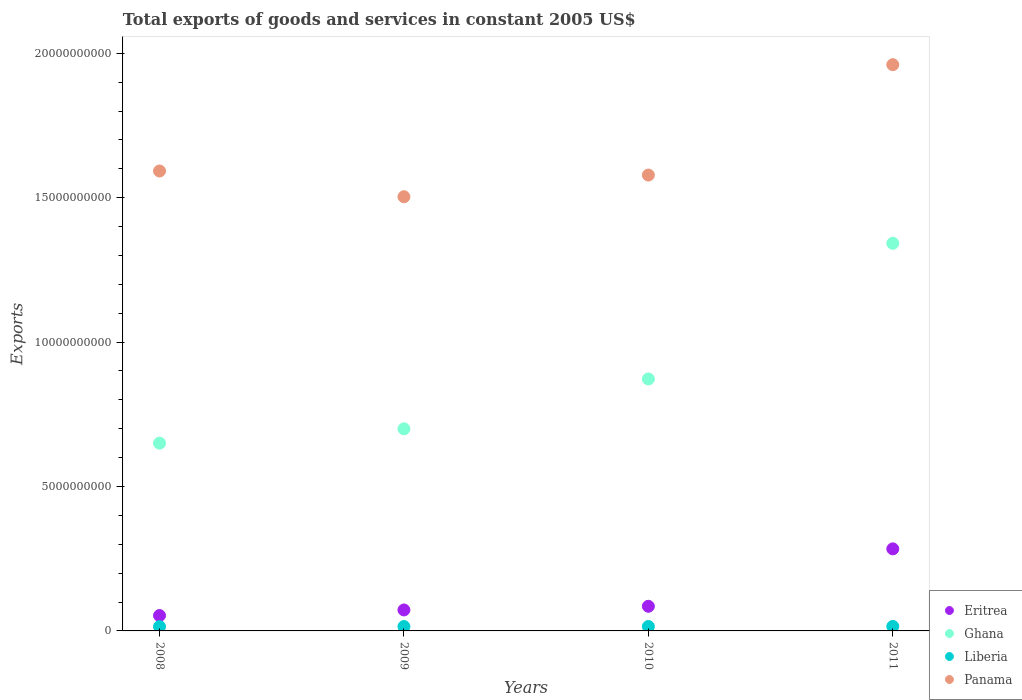How many different coloured dotlines are there?
Your answer should be compact. 4. What is the total exports of goods and services in Eritrea in 2011?
Your answer should be compact. 2.84e+09. Across all years, what is the maximum total exports of goods and services in Liberia?
Make the answer very short. 1.55e+08. Across all years, what is the minimum total exports of goods and services in Ghana?
Ensure brevity in your answer.  6.50e+09. What is the total total exports of goods and services in Liberia in the graph?
Ensure brevity in your answer.  6.09e+08. What is the difference between the total exports of goods and services in Panama in 2009 and that in 2011?
Your answer should be very brief. -4.57e+09. What is the difference between the total exports of goods and services in Ghana in 2008 and the total exports of goods and services in Panama in 2010?
Your answer should be compact. -9.28e+09. What is the average total exports of goods and services in Panama per year?
Give a very brief answer. 1.66e+1. In the year 2010, what is the difference between the total exports of goods and services in Ghana and total exports of goods and services in Panama?
Provide a short and direct response. -7.06e+09. What is the ratio of the total exports of goods and services in Eritrea in 2008 to that in 2011?
Give a very brief answer. 0.19. Is the difference between the total exports of goods and services in Ghana in 2010 and 2011 greater than the difference between the total exports of goods and services in Panama in 2010 and 2011?
Your answer should be compact. No. What is the difference between the highest and the second highest total exports of goods and services in Eritrea?
Ensure brevity in your answer.  1.99e+09. What is the difference between the highest and the lowest total exports of goods and services in Panama?
Your response must be concise. 4.57e+09. In how many years, is the total exports of goods and services in Ghana greater than the average total exports of goods and services in Ghana taken over all years?
Your response must be concise. 1. Is it the case that in every year, the sum of the total exports of goods and services in Panama and total exports of goods and services in Liberia  is greater than the sum of total exports of goods and services in Ghana and total exports of goods and services in Eritrea?
Make the answer very short. No. Does the total exports of goods and services in Ghana monotonically increase over the years?
Give a very brief answer. Yes. Is the total exports of goods and services in Liberia strictly greater than the total exports of goods and services in Eritrea over the years?
Ensure brevity in your answer.  No. How many dotlines are there?
Your answer should be compact. 4. How many years are there in the graph?
Make the answer very short. 4. What is the difference between two consecutive major ticks on the Y-axis?
Your answer should be compact. 5.00e+09. Does the graph contain any zero values?
Your response must be concise. No. Where does the legend appear in the graph?
Give a very brief answer. Bottom right. How are the legend labels stacked?
Your answer should be very brief. Vertical. What is the title of the graph?
Offer a terse response. Total exports of goods and services in constant 2005 US$. What is the label or title of the Y-axis?
Offer a very short reply. Exports. What is the Exports of Eritrea in 2008?
Your answer should be very brief. 5.33e+08. What is the Exports of Ghana in 2008?
Ensure brevity in your answer.  6.50e+09. What is the Exports in Liberia in 2008?
Offer a very short reply. 1.49e+08. What is the Exports in Panama in 2008?
Provide a short and direct response. 1.59e+1. What is the Exports in Eritrea in 2009?
Ensure brevity in your answer.  7.26e+08. What is the Exports in Ghana in 2009?
Your response must be concise. 7.00e+09. What is the Exports in Liberia in 2009?
Your answer should be very brief. 1.51e+08. What is the Exports in Panama in 2009?
Provide a short and direct response. 1.50e+1. What is the Exports of Eritrea in 2010?
Provide a succinct answer. 8.53e+08. What is the Exports of Ghana in 2010?
Make the answer very short. 8.72e+09. What is the Exports of Liberia in 2010?
Your answer should be compact. 1.53e+08. What is the Exports of Panama in 2010?
Give a very brief answer. 1.58e+1. What is the Exports of Eritrea in 2011?
Your answer should be very brief. 2.84e+09. What is the Exports in Ghana in 2011?
Ensure brevity in your answer.  1.34e+1. What is the Exports in Liberia in 2011?
Make the answer very short. 1.55e+08. What is the Exports of Panama in 2011?
Provide a short and direct response. 1.96e+1. Across all years, what is the maximum Exports of Eritrea?
Give a very brief answer. 2.84e+09. Across all years, what is the maximum Exports of Ghana?
Your response must be concise. 1.34e+1. Across all years, what is the maximum Exports of Liberia?
Offer a very short reply. 1.55e+08. Across all years, what is the maximum Exports in Panama?
Give a very brief answer. 1.96e+1. Across all years, what is the minimum Exports in Eritrea?
Provide a short and direct response. 5.33e+08. Across all years, what is the minimum Exports of Ghana?
Your answer should be compact. 6.50e+09. Across all years, what is the minimum Exports of Liberia?
Offer a very short reply. 1.49e+08. Across all years, what is the minimum Exports in Panama?
Your answer should be compact. 1.50e+1. What is the total Exports of Eritrea in the graph?
Offer a very short reply. 4.95e+09. What is the total Exports in Ghana in the graph?
Your answer should be very brief. 3.56e+1. What is the total Exports in Liberia in the graph?
Give a very brief answer. 6.09e+08. What is the total Exports of Panama in the graph?
Make the answer very short. 6.63e+1. What is the difference between the Exports of Eritrea in 2008 and that in 2009?
Your answer should be very brief. -1.93e+08. What is the difference between the Exports of Ghana in 2008 and that in 2009?
Provide a short and direct response. -4.95e+08. What is the difference between the Exports of Liberia in 2008 and that in 2009?
Offer a terse response. -1.98e+06. What is the difference between the Exports in Panama in 2008 and that in 2009?
Offer a terse response. 8.90e+08. What is the difference between the Exports of Eritrea in 2008 and that in 2010?
Make the answer very short. -3.20e+08. What is the difference between the Exports in Ghana in 2008 and that in 2010?
Ensure brevity in your answer.  -2.22e+09. What is the difference between the Exports of Liberia in 2008 and that in 2010?
Your answer should be compact. -3.98e+06. What is the difference between the Exports of Panama in 2008 and that in 2010?
Provide a short and direct response. 1.40e+08. What is the difference between the Exports of Eritrea in 2008 and that in 2011?
Give a very brief answer. -2.31e+09. What is the difference between the Exports in Ghana in 2008 and that in 2011?
Keep it short and to the point. -6.92e+09. What is the difference between the Exports of Liberia in 2008 and that in 2011?
Make the answer very short. -6.07e+06. What is the difference between the Exports of Panama in 2008 and that in 2011?
Your answer should be very brief. -3.68e+09. What is the difference between the Exports in Eritrea in 2009 and that in 2010?
Provide a short and direct response. -1.27e+08. What is the difference between the Exports of Ghana in 2009 and that in 2010?
Provide a succinct answer. -1.73e+09. What is the difference between the Exports of Liberia in 2009 and that in 2010?
Give a very brief answer. -2.00e+06. What is the difference between the Exports in Panama in 2009 and that in 2010?
Your answer should be compact. -7.51e+08. What is the difference between the Exports in Eritrea in 2009 and that in 2011?
Your answer should be very brief. -2.12e+09. What is the difference between the Exports of Ghana in 2009 and that in 2011?
Your answer should be compact. -6.42e+09. What is the difference between the Exports of Liberia in 2009 and that in 2011?
Provide a succinct answer. -4.09e+06. What is the difference between the Exports in Panama in 2009 and that in 2011?
Give a very brief answer. -4.57e+09. What is the difference between the Exports in Eritrea in 2010 and that in 2011?
Your answer should be compact. -1.99e+09. What is the difference between the Exports in Ghana in 2010 and that in 2011?
Your response must be concise. -4.70e+09. What is the difference between the Exports of Liberia in 2010 and that in 2011?
Provide a short and direct response. -2.09e+06. What is the difference between the Exports in Panama in 2010 and that in 2011?
Offer a very short reply. -3.82e+09. What is the difference between the Exports of Eritrea in 2008 and the Exports of Ghana in 2009?
Ensure brevity in your answer.  -6.46e+09. What is the difference between the Exports in Eritrea in 2008 and the Exports in Liberia in 2009?
Offer a very short reply. 3.82e+08. What is the difference between the Exports in Eritrea in 2008 and the Exports in Panama in 2009?
Offer a terse response. -1.45e+1. What is the difference between the Exports in Ghana in 2008 and the Exports in Liberia in 2009?
Your response must be concise. 6.35e+09. What is the difference between the Exports in Ghana in 2008 and the Exports in Panama in 2009?
Ensure brevity in your answer.  -8.53e+09. What is the difference between the Exports of Liberia in 2008 and the Exports of Panama in 2009?
Provide a short and direct response. -1.49e+1. What is the difference between the Exports of Eritrea in 2008 and the Exports of Ghana in 2010?
Your answer should be compact. -8.19e+09. What is the difference between the Exports of Eritrea in 2008 and the Exports of Liberia in 2010?
Provide a short and direct response. 3.80e+08. What is the difference between the Exports of Eritrea in 2008 and the Exports of Panama in 2010?
Your response must be concise. -1.52e+1. What is the difference between the Exports of Ghana in 2008 and the Exports of Liberia in 2010?
Provide a short and direct response. 6.35e+09. What is the difference between the Exports in Ghana in 2008 and the Exports in Panama in 2010?
Your answer should be very brief. -9.28e+09. What is the difference between the Exports of Liberia in 2008 and the Exports of Panama in 2010?
Your answer should be compact. -1.56e+1. What is the difference between the Exports of Eritrea in 2008 and the Exports of Ghana in 2011?
Give a very brief answer. -1.29e+1. What is the difference between the Exports in Eritrea in 2008 and the Exports in Liberia in 2011?
Ensure brevity in your answer.  3.78e+08. What is the difference between the Exports of Eritrea in 2008 and the Exports of Panama in 2011?
Offer a terse response. -1.91e+1. What is the difference between the Exports in Ghana in 2008 and the Exports in Liberia in 2011?
Provide a succinct answer. 6.35e+09. What is the difference between the Exports of Ghana in 2008 and the Exports of Panama in 2011?
Ensure brevity in your answer.  -1.31e+1. What is the difference between the Exports in Liberia in 2008 and the Exports in Panama in 2011?
Offer a terse response. -1.95e+1. What is the difference between the Exports in Eritrea in 2009 and the Exports in Ghana in 2010?
Your answer should be very brief. -8.00e+09. What is the difference between the Exports in Eritrea in 2009 and the Exports in Liberia in 2010?
Your response must be concise. 5.73e+08. What is the difference between the Exports of Eritrea in 2009 and the Exports of Panama in 2010?
Keep it short and to the point. -1.51e+1. What is the difference between the Exports of Ghana in 2009 and the Exports of Liberia in 2010?
Make the answer very short. 6.84e+09. What is the difference between the Exports of Ghana in 2009 and the Exports of Panama in 2010?
Give a very brief answer. -8.79e+09. What is the difference between the Exports of Liberia in 2009 and the Exports of Panama in 2010?
Provide a short and direct response. -1.56e+1. What is the difference between the Exports in Eritrea in 2009 and the Exports in Ghana in 2011?
Offer a terse response. -1.27e+1. What is the difference between the Exports of Eritrea in 2009 and the Exports of Liberia in 2011?
Offer a very short reply. 5.71e+08. What is the difference between the Exports in Eritrea in 2009 and the Exports in Panama in 2011?
Offer a terse response. -1.89e+1. What is the difference between the Exports of Ghana in 2009 and the Exports of Liberia in 2011?
Offer a terse response. 6.84e+09. What is the difference between the Exports in Ghana in 2009 and the Exports in Panama in 2011?
Provide a short and direct response. -1.26e+1. What is the difference between the Exports in Liberia in 2009 and the Exports in Panama in 2011?
Your answer should be compact. -1.95e+1. What is the difference between the Exports in Eritrea in 2010 and the Exports in Ghana in 2011?
Your answer should be compact. -1.26e+1. What is the difference between the Exports of Eritrea in 2010 and the Exports of Liberia in 2011?
Give a very brief answer. 6.98e+08. What is the difference between the Exports of Eritrea in 2010 and the Exports of Panama in 2011?
Offer a very short reply. -1.88e+1. What is the difference between the Exports in Ghana in 2010 and the Exports in Liberia in 2011?
Provide a succinct answer. 8.57e+09. What is the difference between the Exports of Ghana in 2010 and the Exports of Panama in 2011?
Offer a very short reply. -1.09e+1. What is the difference between the Exports in Liberia in 2010 and the Exports in Panama in 2011?
Your response must be concise. -1.95e+1. What is the average Exports of Eritrea per year?
Offer a very short reply. 1.24e+09. What is the average Exports in Ghana per year?
Offer a terse response. 8.91e+09. What is the average Exports in Liberia per year?
Your answer should be very brief. 1.52e+08. What is the average Exports in Panama per year?
Ensure brevity in your answer.  1.66e+1. In the year 2008, what is the difference between the Exports in Eritrea and Exports in Ghana?
Give a very brief answer. -5.97e+09. In the year 2008, what is the difference between the Exports in Eritrea and Exports in Liberia?
Ensure brevity in your answer.  3.84e+08. In the year 2008, what is the difference between the Exports in Eritrea and Exports in Panama?
Provide a succinct answer. -1.54e+1. In the year 2008, what is the difference between the Exports in Ghana and Exports in Liberia?
Provide a succinct answer. 6.35e+09. In the year 2008, what is the difference between the Exports of Ghana and Exports of Panama?
Make the answer very short. -9.42e+09. In the year 2008, what is the difference between the Exports in Liberia and Exports in Panama?
Provide a succinct answer. -1.58e+1. In the year 2009, what is the difference between the Exports in Eritrea and Exports in Ghana?
Offer a very short reply. -6.27e+09. In the year 2009, what is the difference between the Exports in Eritrea and Exports in Liberia?
Provide a short and direct response. 5.75e+08. In the year 2009, what is the difference between the Exports in Eritrea and Exports in Panama?
Ensure brevity in your answer.  -1.43e+1. In the year 2009, what is the difference between the Exports of Ghana and Exports of Liberia?
Ensure brevity in your answer.  6.84e+09. In the year 2009, what is the difference between the Exports of Ghana and Exports of Panama?
Give a very brief answer. -8.04e+09. In the year 2009, what is the difference between the Exports in Liberia and Exports in Panama?
Your response must be concise. -1.49e+1. In the year 2010, what is the difference between the Exports of Eritrea and Exports of Ghana?
Make the answer very short. -7.87e+09. In the year 2010, what is the difference between the Exports of Eritrea and Exports of Liberia?
Offer a very short reply. 7.00e+08. In the year 2010, what is the difference between the Exports of Eritrea and Exports of Panama?
Ensure brevity in your answer.  -1.49e+1. In the year 2010, what is the difference between the Exports in Ghana and Exports in Liberia?
Ensure brevity in your answer.  8.57e+09. In the year 2010, what is the difference between the Exports in Ghana and Exports in Panama?
Ensure brevity in your answer.  -7.06e+09. In the year 2010, what is the difference between the Exports of Liberia and Exports of Panama?
Make the answer very short. -1.56e+1. In the year 2011, what is the difference between the Exports of Eritrea and Exports of Ghana?
Your response must be concise. -1.06e+1. In the year 2011, what is the difference between the Exports of Eritrea and Exports of Liberia?
Ensure brevity in your answer.  2.69e+09. In the year 2011, what is the difference between the Exports in Eritrea and Exports in Panama?
Offer a terse response. -1.68e+1. In the year 2011, what is the difference between the Exports in Ghana and Exports in Liberia?
Your response must be concise. 1.33e+1. In the year 2011, what is the difference between the Exports of Ghana and Exports of Panama?
Make the answer very short. -6.18e+09. In the year 2011, what is the difference between the Exports in Liberia and Exports in Panama?
Your answer should be very brief. -1.94e+1. What is the ratio of the Exports in Eritrea in 2008 to that in 2009?
Make the answer very short. 0.73. What is the ratio of the Exports of Ghana in 2008 to that in 2009?
Offer a terse response. 0.93. What is the ratio of the Exports in Liberia in 2008 to that in 2009?
Give a very brief answer. 0.99. What is the ratio of the Exports of Panama in 2008 to that in 2009?
Your answer should be very brief. 1.06. What is the ratio of the Exports in Eritrea in 2008 to that in 2010?
Your response must be concise. 0.62. What is the ratio of the Exports of Ghana in 2008 to that in 2010?
Offer a very short reply. 0.75. What is the ratio of the Exports of Panama in 2008 to that in 2010?
Offer a terse response. 1.01. What is the ratio of the Exports in Eritrea in 2008 to that in 2011?
Your response must be concise. 0.19. What is the ratio of the Exports of Ghana in 2008 to that in 2011?
Keep it short and to the point. 0.48. What is the ratio of the Exports in Liberia in 2008 to that in 2011?
Ensure brevity in your answer.  0.96. What is the ratio of the Exports of Panama in 2008 to that in 2011?
Your answer should be compact. 0.81. What is the ratio of the Exports in Eritrea in 2009 to that in 2010?
Keep it short and to the point. 0.85. What is the ratio of the Exports of Ghana in 2009 to that in 2010?
Provide a short and direct response. 0.8. What is the ratio of the Exports of Liberia in 2009 to that in 2010?
Provide a succinct answer. 0.99. What is the ratio of the Exports of Panama in 2009 to that in 2010?
Offer a terse response. 0.95. What is the ratio of the Exports of Eritrea in 2009 to that in 2011?
Your answer should be very brief. 0.26. What is the ratio of the Exports of Ghana in 2009 to that in 2011?
Your response must be concise. 0.52. What is the ratio of the Exports in Liberia in 2009 to that in 2011?
Offer a very short reply. 0.97. What is the ratio of the Exports in Panama in 2009 to that in 2011?
Your response must be concise. 0.77. What is the ratio of the Exports of Eritrea in 2010 to that in 2011?
Offer a very short reply. 0.3. What is the ratio of the Exports in Ghana in 2010 to that in 2011?
Your answer should be very brief. 0.65. What is the ratio of the Exports of Liberia in 2010 to that in 2011?
Your response must be concise. 0.99. What is the ratio of the Exports of Panama in 2010 to that in 2011?
Offer a terse response. 0.81. What is the difference between the highest and the second highest Exports of Eritrea?
Offer a very short reply. 1.99e+09. What is the difference between the highest and the second highest Exports in Ghana?
Your response must be concise. 4.70e+09. What is the difference between the highest and the second highest Exports of Liberia?
Your answer should be very brief. 2.09e+06. What is the difference between the highest and the second highest Exports in Panama?
Provide a short and direct response. 3.68e+09. What is the difference between the highest and the lowest Exports of Eritrea?
Provide a succinct answer. 2.31e+09. What is the difference between the highest and the lowest Exports of Ghana?
Provide a short and direct response. 6.92e+09. What is the difference between the highest and the lowest Exports of Liberia?
Provide a succinct answer. 6.07e+06. What is the difference between the highest and the lowest Exports in Panama?
Your answer should be very brief. 4.57e+09. 